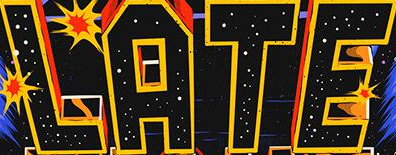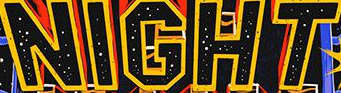Transcribe the words shown in these images in order, separated by a semicolon. LATE; NIGHT 